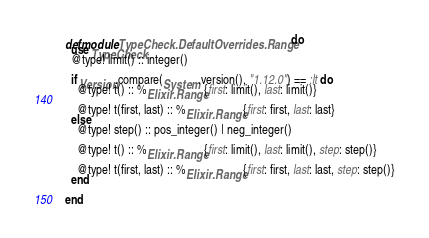Convert code to text. <code><loc_0><loc_0><loc_500><loc_500><_Elixir_>defmodule TypeCheck.DefaultOverrides.Range do
  use TypeCheck
  @type! limit() :: integer()

  if Version.compare(System.version(), "1.12.0") == :lt do
    @type! t() :: %Elixir.Range{first: limit(), last: limit()}

    @type! t(first, last) :: %Elixir.Range{first: first, last: last}
  else
    @type! step() :: pos_integer() | neg_integer()

    @type! t() :: %Elixir.Range{first: limit(), last: limit(), step: step()}

    @type! t(first, last) :: %Elixir.Range{first: first, last: last, step: step()}
  end

end
</code> 